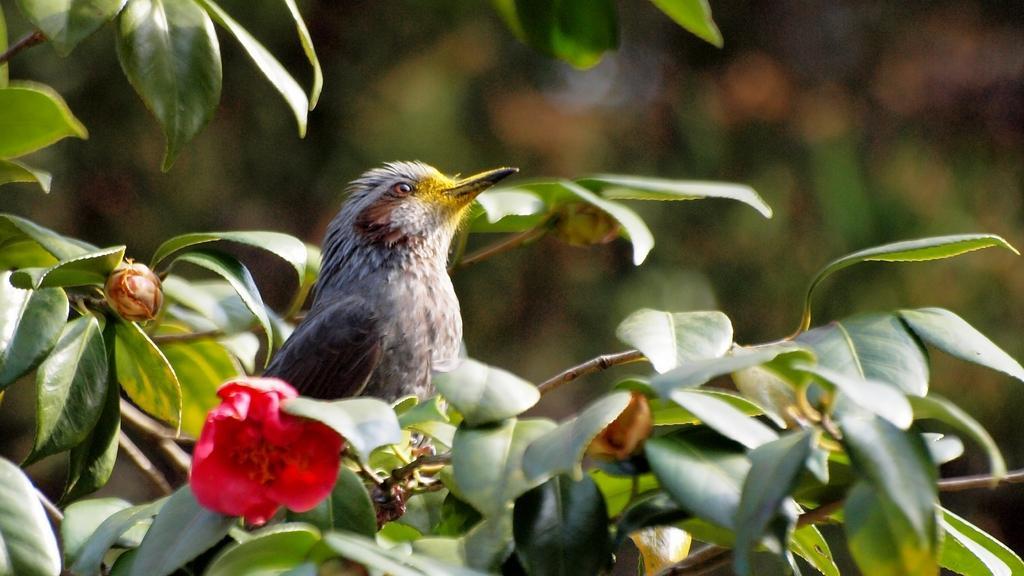Could you give a brief overview of what you see in this image? In the image there is a bird sitting on a branch of a plant, beside the bird there is a a pink flower. 